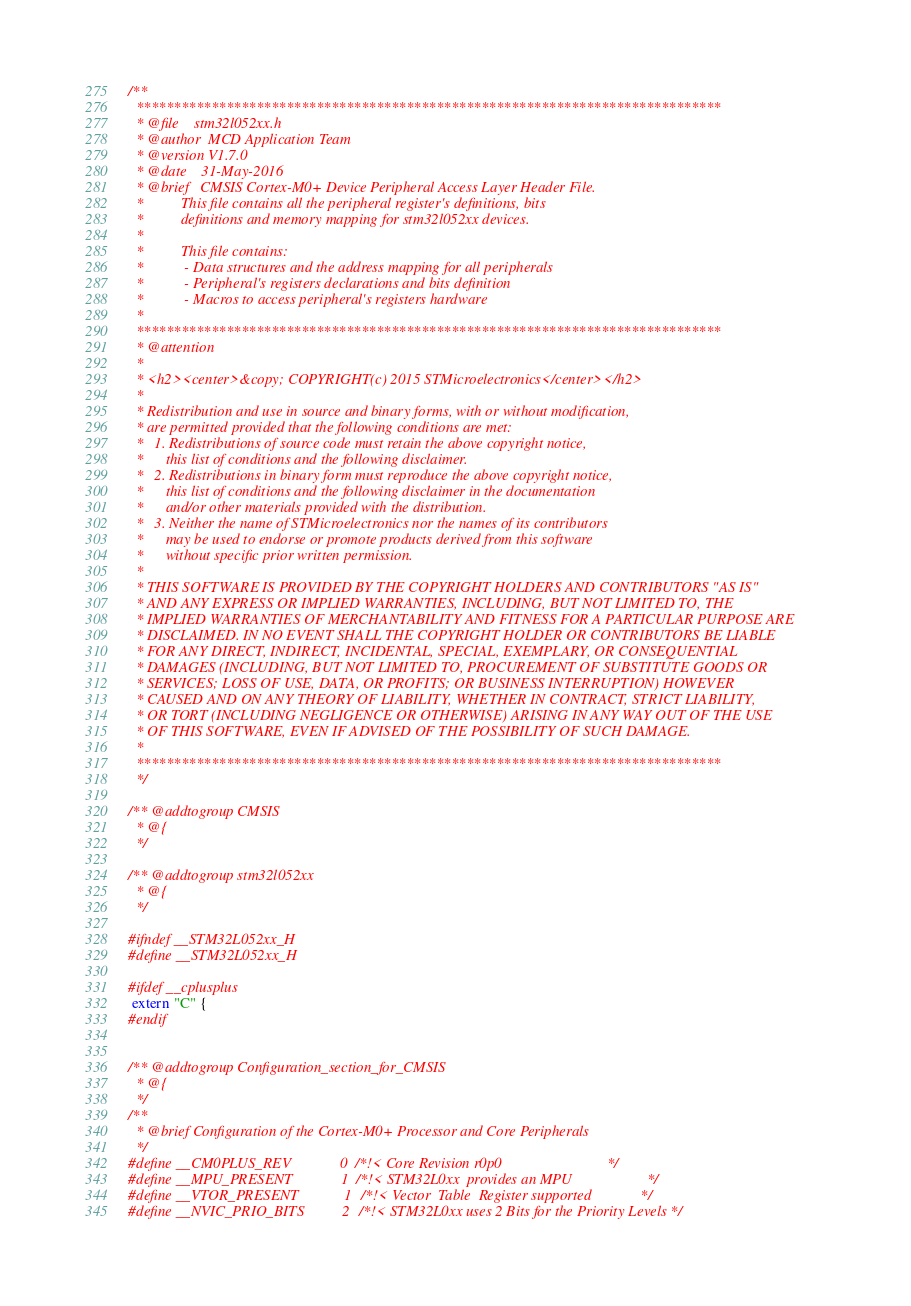<code> <loc_0><loc_0><loc_500><loc_500><_C_>/**
  ******************************************************************************
  * @file    stm32l052xx.h
  * @author  MCD Application Team
  * @version V1.7.0
  * @date    31-May-2016
  * @brief   CMSIS Cortex-M0+ Device Peripheral Access Layer Header File.
  *          This file contains all the peripheral register's definitions, bits
  *          definitions and memory mapping for stm32l052xx devices.
  *
  *          This file contains:
  *           - Data structures and the address mapping for all peripherals
  *           - Peripheral's registers declarations and bits definition
  *           - Macros to access peripheral's registers hardware
  *
  ******************************************************************************
  * @attention
  *
  * <h2><center>&copy; COPYRIGHT(c) 2015 STMicroelectronics</center></h2>
  *
  * Redistribution and use in source and binary forms, with or without modification,
  * are permitted provided that the following conditions are met:
  *   1. Redistributions of source code must retain the above copyright notice,
  *      this list of conditions and the following disclaimer.
  *   2. Redistributions in binary form must reproduce the above copyright notice,
  *      this list of conditions and the following disclaimer in the documentation
  *      and/or other materials provided with the distribution.
  *   3. Neither the name of STMicroelectronics nor the names of its contributors
  *      may be used to endorse or promote products derived from this software
  *      without specific prior written permission.
  *
  * THIS SOFTWARE IS PROVIDED BY THE COPYRIGHT HOLDERS AND CONTRIBUTORS "AS IS"
  * AND ANY EXPRESS OR IMPLIED WARRANTIES, INCLUDING, BUT NOT LIMITED TO, THE
  * IMPLIED WARRANTIES OF MERCHANTABILITY AND FITNESS FOR A PARTICULAR PURPOSE ARE
  * DISCLAIMED. IN NO EVENT SHALL THE COPYRIGHT HOLDER OR CONTRIBUTORS BE LIABLE
  * FOR ANY DIRECT, INDIRECT, INCIDENTAL, SPECIAL, EXEMPLARY, OR CONSEQUENTIAL
  * DAMAGES (INCLUDING, BUT NOT LIMITED TO, PROCUREMENT OF SUBSTITUTE GOODS OR
  * SERVICES; LOSS OF USE, DATA, OR PROFITS; OR BUSINESS INTERRUPTION) HOWEVER
  * CAUSED AND ON ANY THEORY OF LIABILITY, WHETHER IN CONTRACT, STRICT LIABILITY,
  * OR TORT (INCLUDING NEGLIGENCE OR OTHERWISE) ARISING IN ANY WAY OUT OF THE USE
  * OF THIS SOFTWARE, EVEN IF ADVISED OF THE POSSIBILITY OF SUCH DAMAGE.
  *
  ******************************************************************************
  */

/** @addtogroup CMSIS
  * @{
  */

/** @addtogroup stm32l052xx
  * @{
  */

#ifndef __STM32L052xx_H
#define __STM32L052xx_H

#ifdef __cplusplus
 extern "C" {
#endif


/** @addtogroup Configuration_section_for_CMSIS
  * @{
  */
/**
  * @brief Configuration of the Cortex-M0+ Processor and Core Peripherals
  */
#define __CM0PLUS_REV             0 /*!< Core Revision r0p0                            */
#define __MPU_PRESENT             1 /*!< STM32L0xx  provides an MPU                    */
#define __VTOR_PRESENT            1 /*!< Vector  Table  Register supported             */
#define __NVIC_PRIO_BITS          2 /*!< STM32L0xx uses 2 Bits for the Priority Levels */</code> 